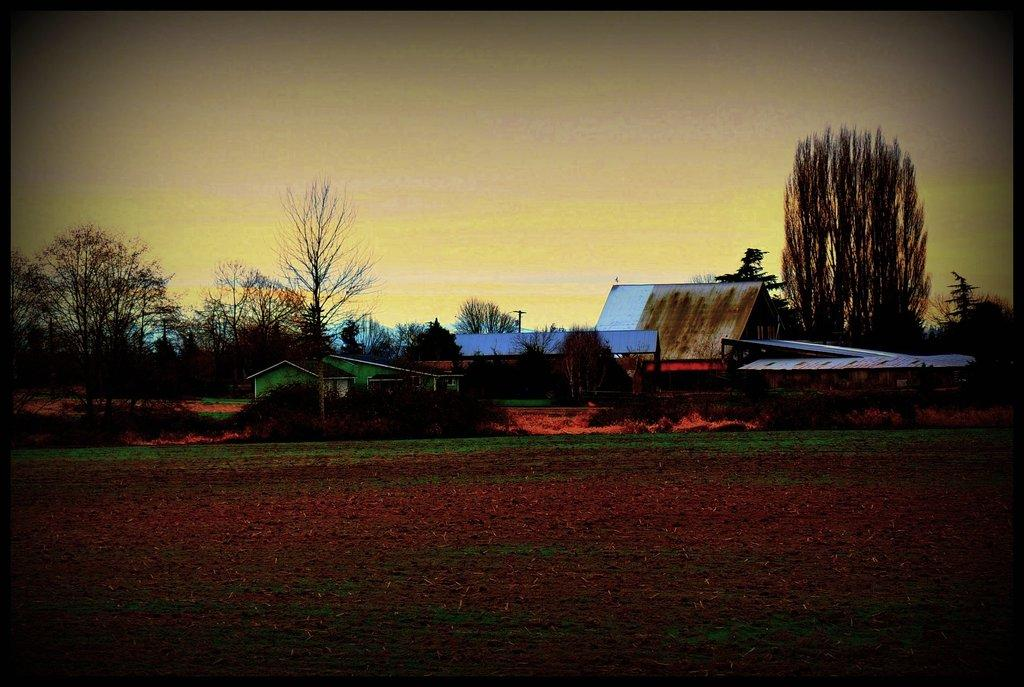What type of structures can be seen in the image? There are buildings in the image. What type of vegetation is present in the image? There are trees in the image. How many scarecrows are visible in the image? There are no scarecrows present in the image. What type of weapon is mounted on the cannon in the image? There is no cannon present in the image. 